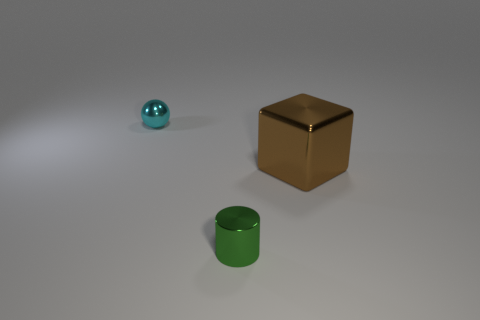Add 2 tiny purple shiny spheres. How many objects exist? 5 Subtract 1 blocks. How many blocks are left? 0 Subtract all balls. How many objects are left? 2 Subtract all big brown matte balls. Subtract all shiny spheres. How many objects are left? 2 Add 3 small cyan objects. How many small cyan objects are left? 4 Add 3 large gray matte cubes. How many large gray matte cubes exist? 3 Subtract 1 brown cubes. How many objects are left? 2 Subtract all red cubes. Subtract all gray spheres. How many cubes are left? 1 Subtract all cyan cylinders. How many red cubes are left? 0 